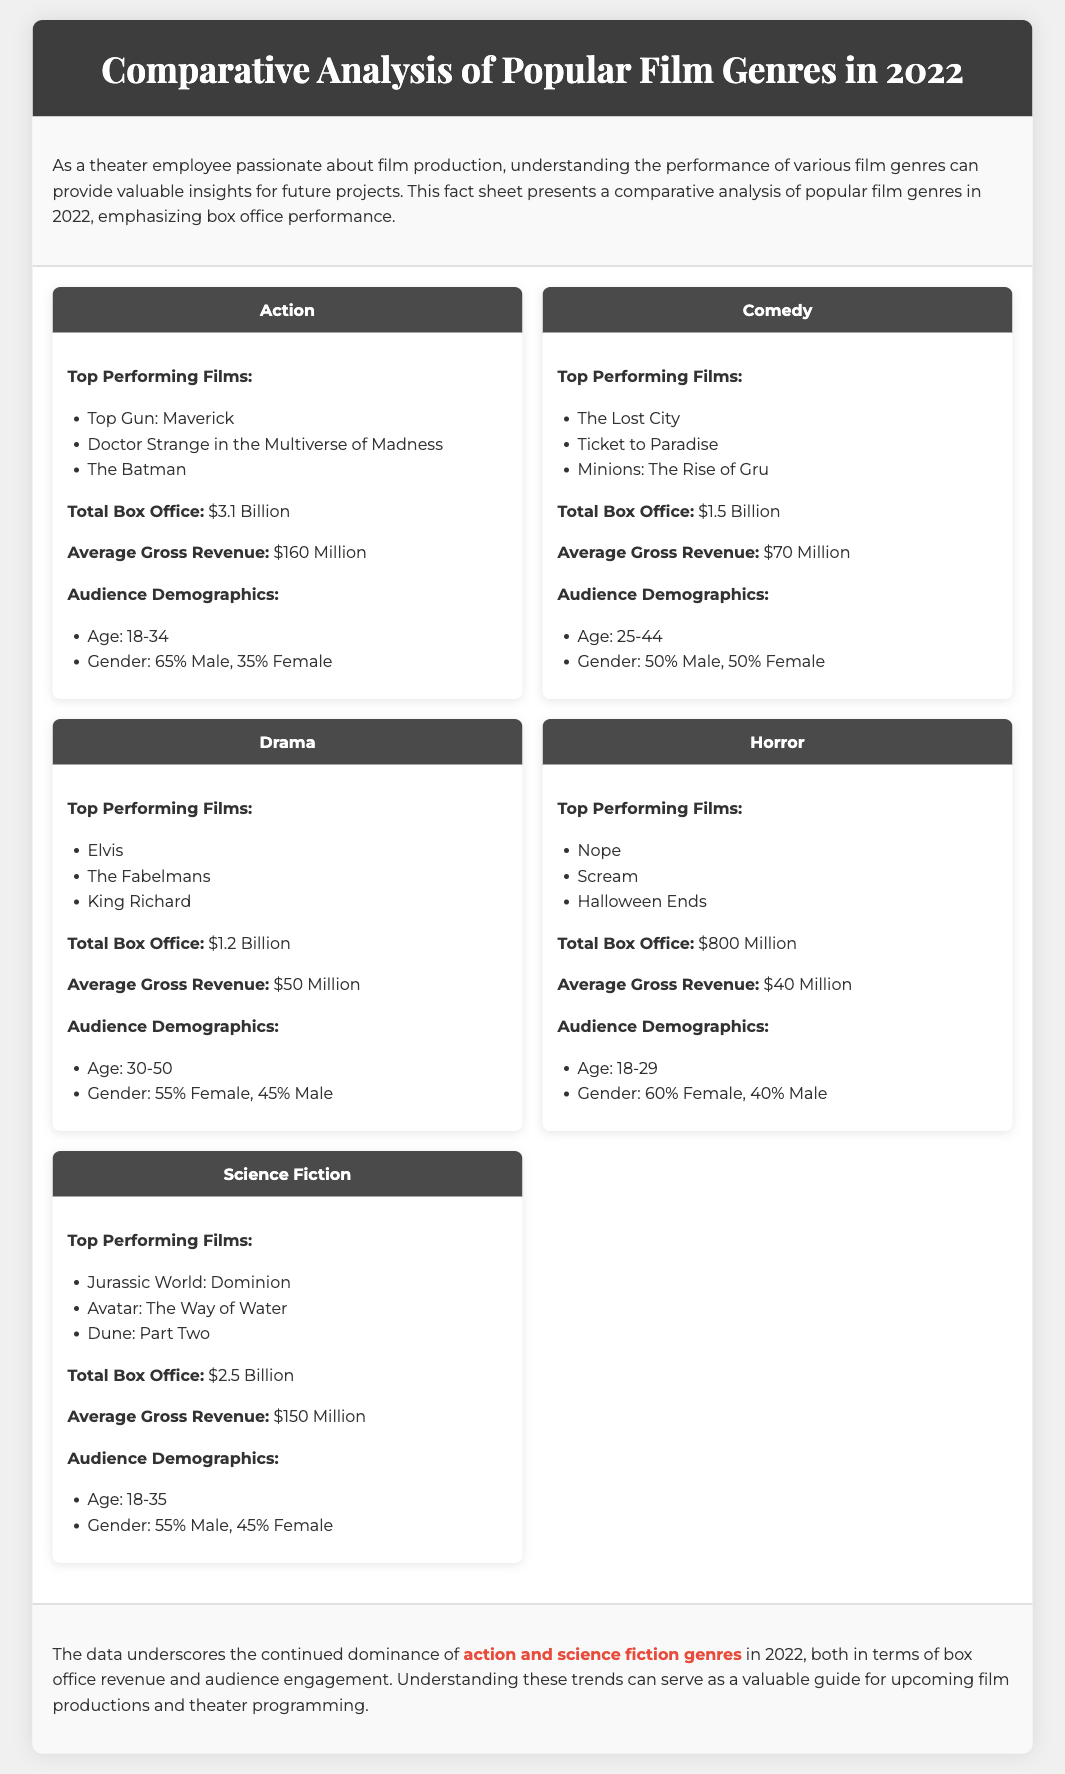What is the total box office for the Action genre? The total box office for the Action genre is listed in the document as $3.1 Billion.
Answer: $3.1 Billion Which film topped the Comedy genre in 2022? The top-performing film in the Comedy genre is specified as The Lost City in the document.
Answer: The Lost City What percentage of the audience for Horror films were male? The document states that 40% of the audience for Horror films were male.
Answer: 40% Which genre had the highest average gross revenue? To find the highest average gross revenue, we compare the average revenues of all genres; Action has the highest at $160 Million.
Answer: $160 Million How much did the Drama genre earn at the box office? The total box office for the Drama genre is given in the document as $1.2 Billion.
Answer: $1.2 Billion What age range is most common for the Science Fiction audience? The age range for the Science Fiction audience is mentioned as 18-35 in the document.
Answer: 18-35 What is the total box office for the Comedy genre? The document specifies the total box office for the Comedy genre as $1.5 Billion.
Answer: $1.5 Billion Which genre’s audience is predominantly female? The document states that the Horror genre's audience is predominantly female, with 60% female viewers.
Answer: Horror What is highlighted as the dominant genre in 2022? The document highlights action and science fiction genres as the dominant genres of 2022.
Answer: action and science fiction genres 